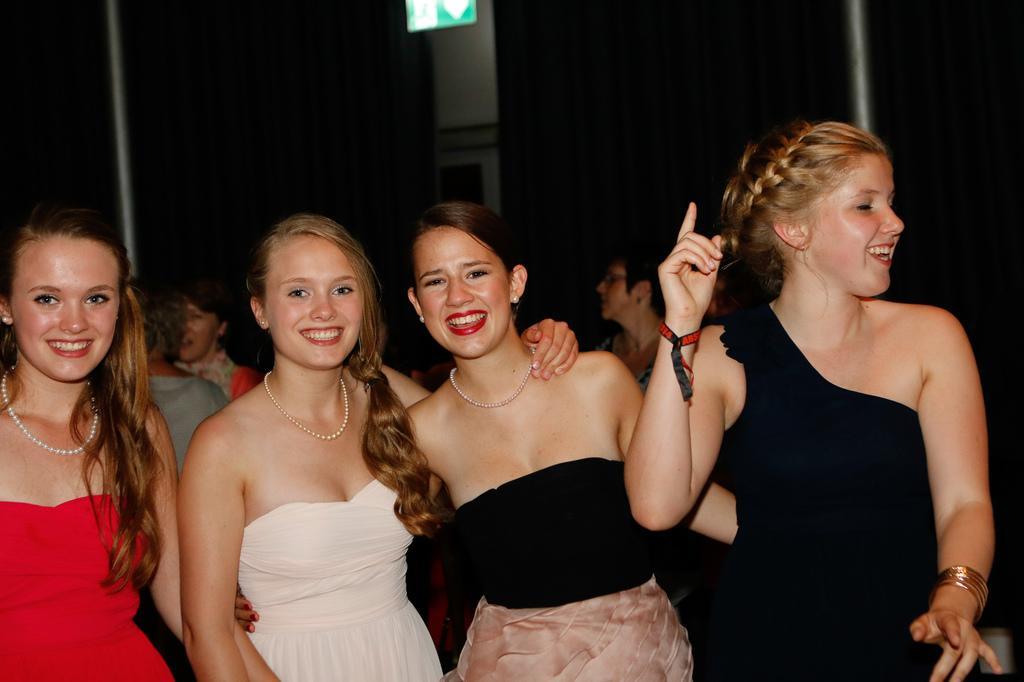Describe this image in one or two sentences. In the image there are few girls standing and all people are smiling, behind them its all dark. 